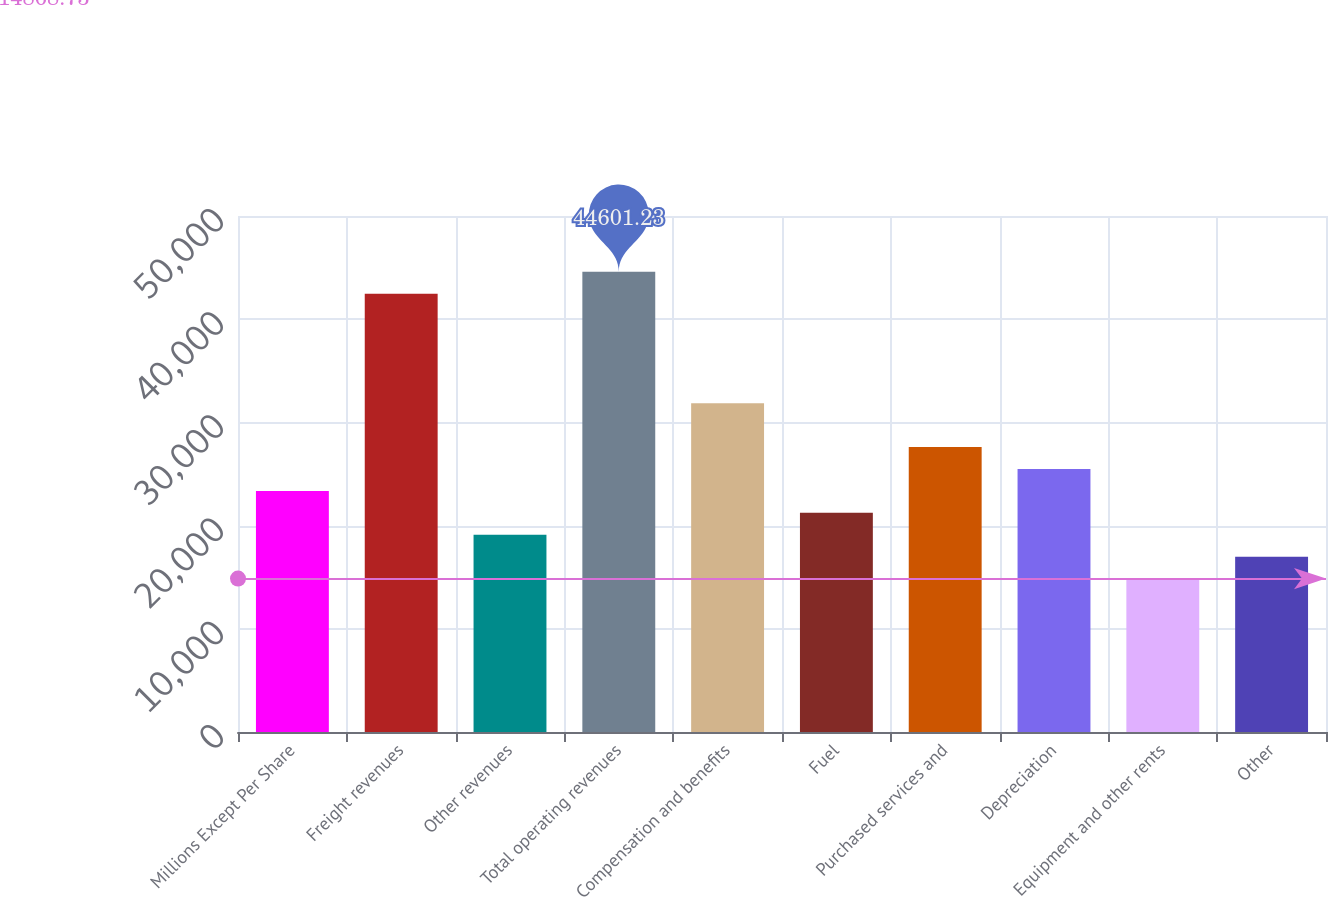Convert chart to OTSL. <chart><loc_0><loc_0><loc_500><loc_500><bar_chart><fcel>Millions Except Per Share<fcel>Freight revenues<fcel>Other revenues<fcel>Total operating revenues<fcel>Compensation and benefits<fcel>Fuel<fcel>Purchased services and<fcel>Depreciation<fcel>Equipment and other rents<fcel>Other<nl><fcel>23363.7<fcel>42477.5<fcel>19116.2<fcel>44601.2<fcel>31858.7<fcel>21240<fcel>27611.2<fcel>25487.5<fcel>14868.7<fcel>16992.5<nl></chart> 